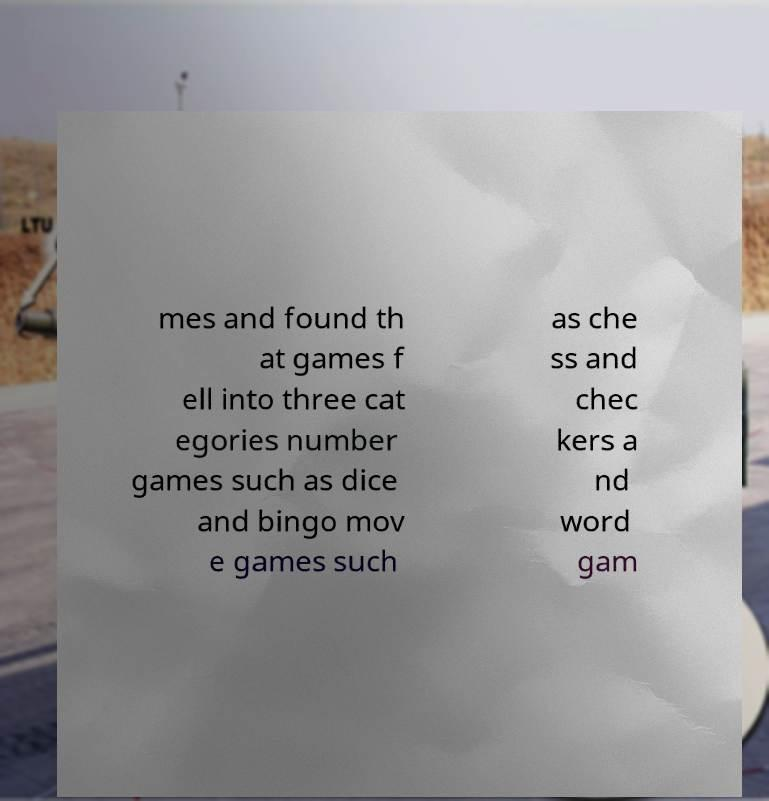Please identify and transcribe the text found in this image. mes and found th at games f ell into three cat egories number games such as dice and bingo mov e games such as che ss and chec kers a nd word gam 